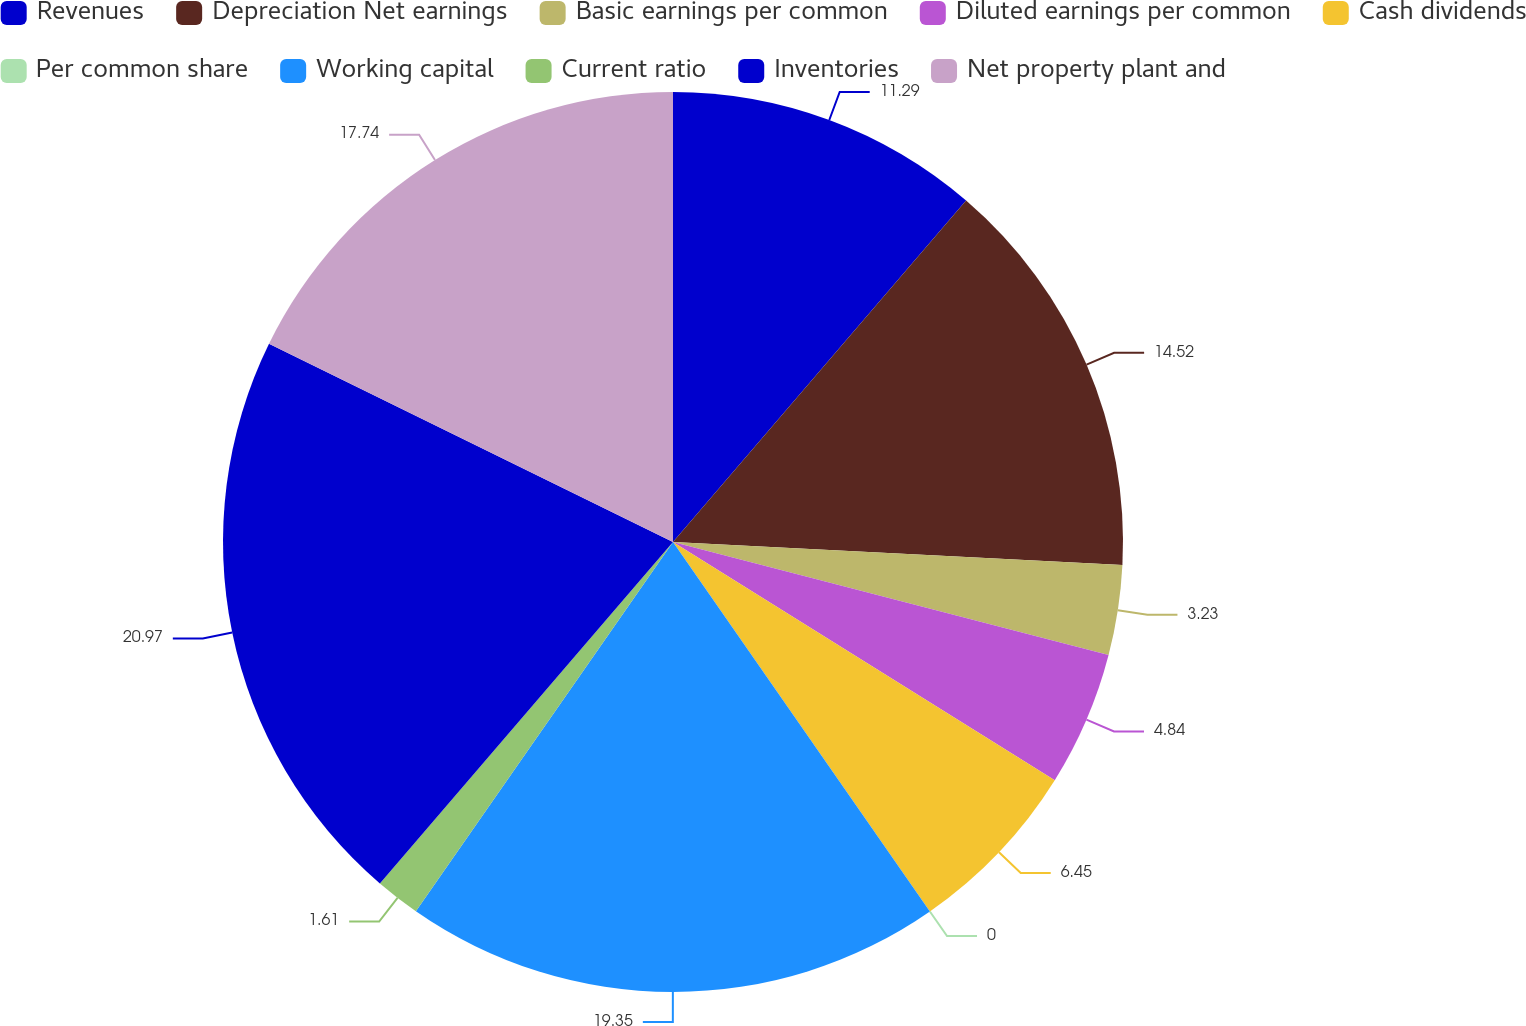Convert chart to OTSL. <chart><loc_0><loc_0><loc_500><loc_500><pie_chart><fcel>Revenues<fcel>Depreciation Net earnings<fcel>Basic earnings per common<fcel>Diluted earnings per common<fcel>Cash dividends<fcel>Per common share<fcel>Working capital<fcel>Current ratio<fcel>Inventories<fcel>Net property plant and<nl><fcel>11.29%<fcel>14.52%<fcel>3.23%<fcel>4.84%<fcel>6.45%<fcel>0.0%<fcel>19.35%<fcel>1.61%<fcel>20.97%<fcel>17.74%<nl></chart> 